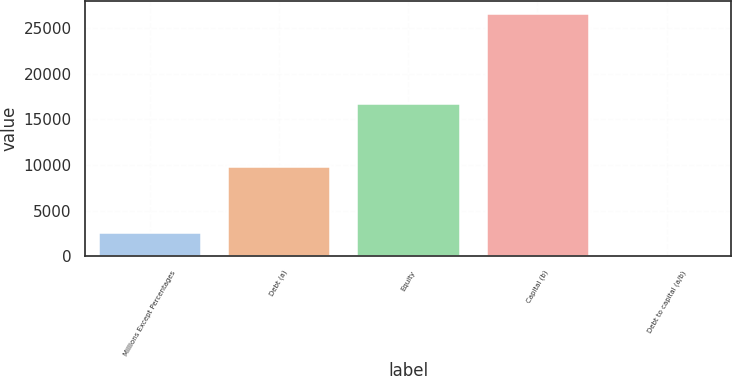Convert chart. <chart><loc_0><loc_0><loc_500><loc_500><bar_chart><fcel>Millions Except Percentages<fcel>Debt (a)<fcel>Equity<fcel>Capital (b)<fcel>Debt to capital (a/b)<nl><fcel>2698.2<fcel>9848<fcel>16801<fcel>26649<fcel>37<nl></chart> 